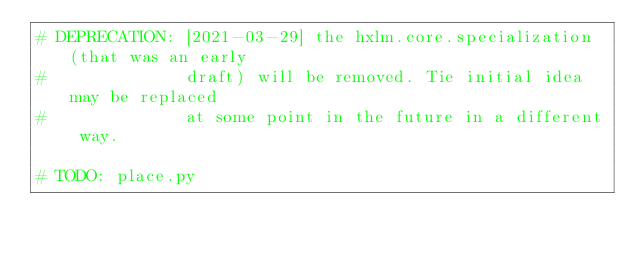<code> <loc_0><loc_0><loc_500><loc_500><_Python_># DEPRECATION: [2021-03-29] the hxlm.core.specialization (that was an early
#              draft) will be removed. Tie initial idea may be replaced
#              at some point in the future in a different way.

# TODO: place.py
</code> 